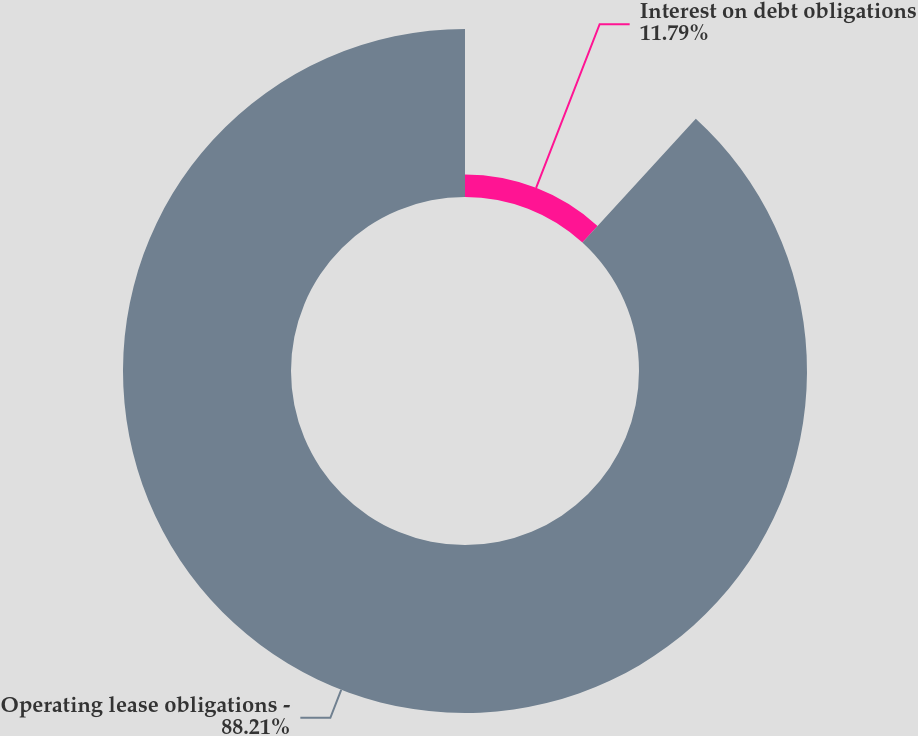Convert chart. <chart><loc_0><loc_0><loc_500><loc_500><pie_chart><fcel>Interest on debt obligations<fcel>Operating lease obligations -<nl><fcel>11.79%<fcel>88.21%<nl></chart> 